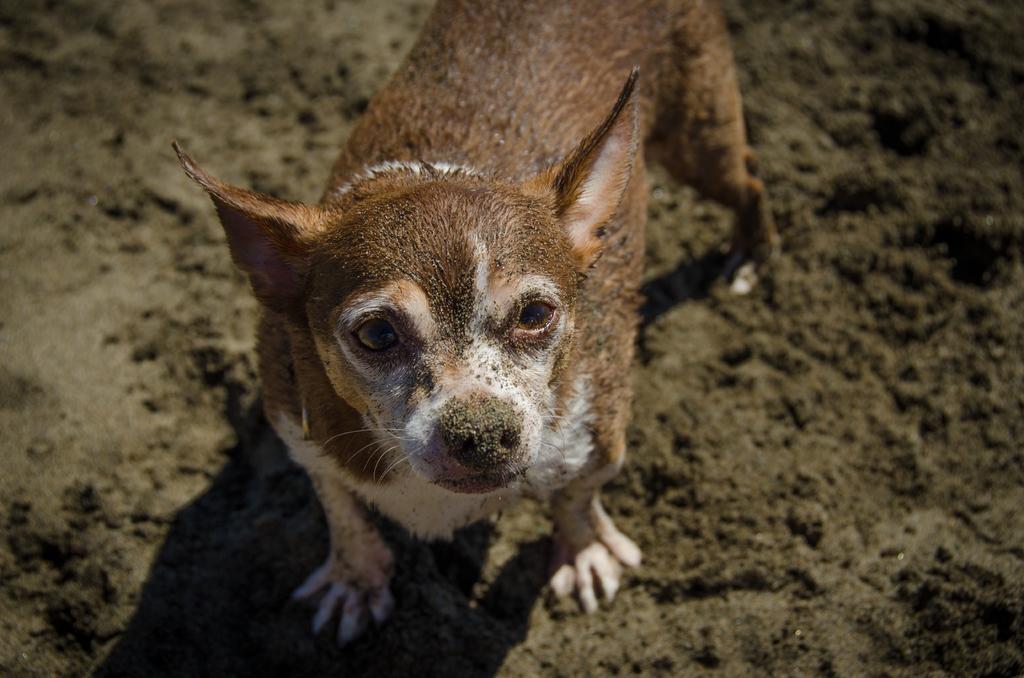Could you give a brief overview of what you see in this image? In this image there is a dog standing. 